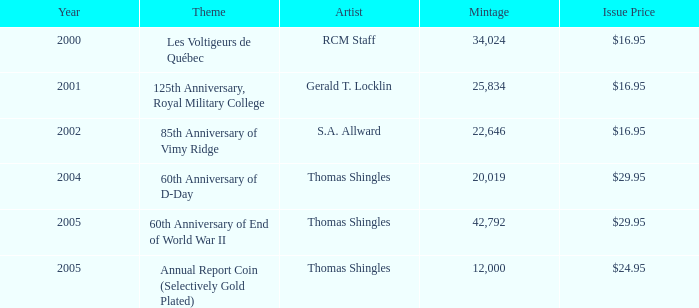What year did s.a. allward's theme having a release price of $1 2002.0. Help me parse the entirety of this table. {'header': ['Year', 'Theme', 'Artist', 'Mintage', 'Issue Price'], 'rows': [['2000', 'Les Voltigeurs de Québec', 'RCM Staff', '34,024', '$16.95'], ['2001', '125th Anniversary, Royal Military College', 'Gerald T. Locklin', '25,834', '$16.95'], ['2002', '85th Anniversary of Vimy Ridge', 'S.A. Allward', '22,646', '$16.95'], ['2004', '60th Anniversary of D-Day', 'Thomas Shingles', '20,019', '$29.95'], ['2005', '60th Anniversary of End of World War II', 'Thomas Shingles', '42,792', '$29.95'], ['2005', 'Annual Report Coin (Selectively Gold Plated)', 'Thomas Shingles', '12,000', '$24.95']]} 